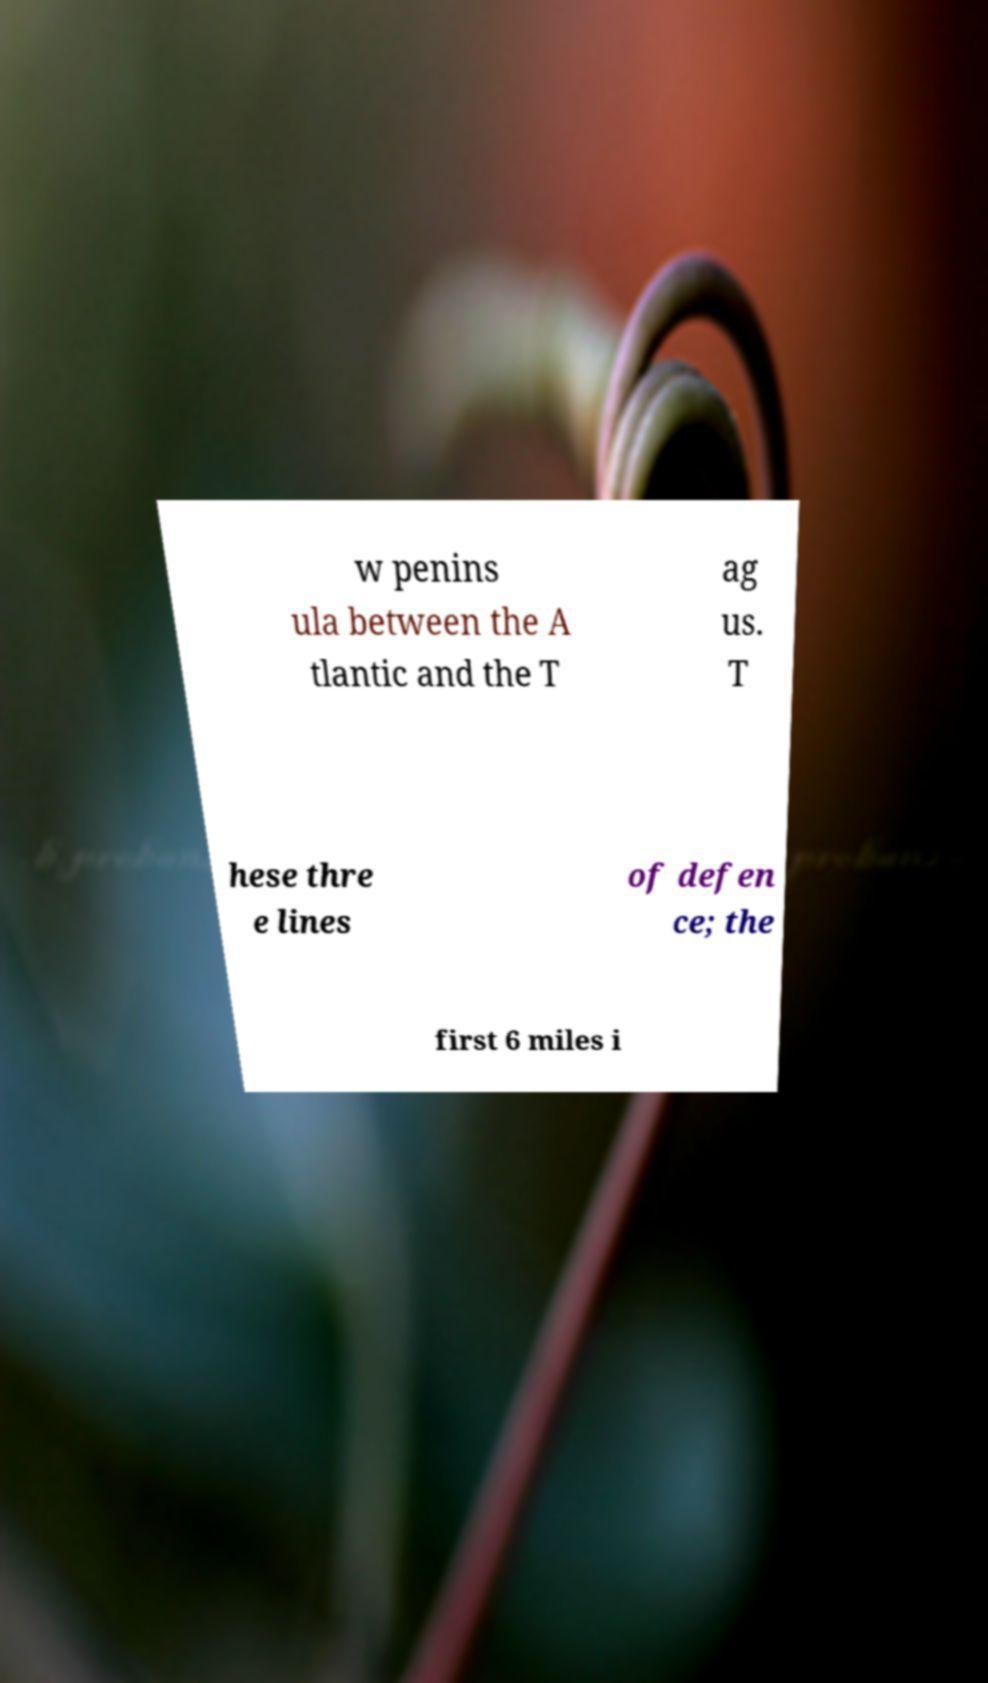For documentation purposes, I need the text within this image transcribed. Could you provide that? w penins ula between the A tlantic and the T ag us. T hese thre e lines of defen ce; the first 6 miles i 